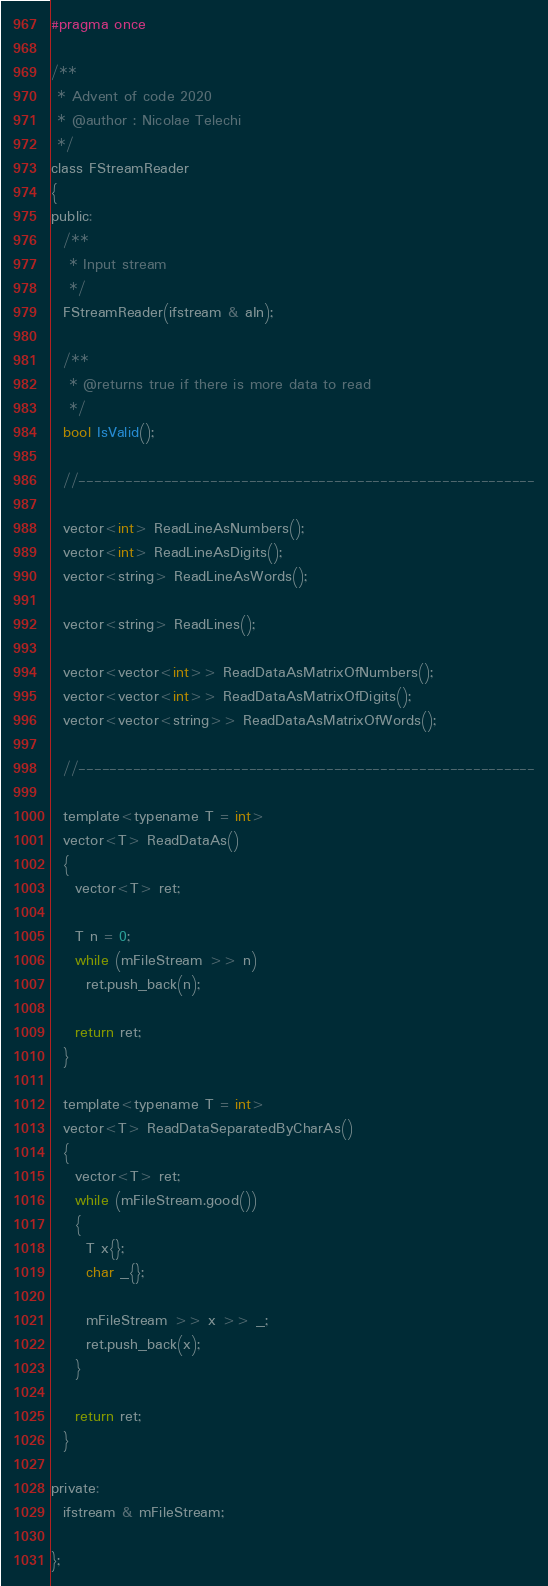Convert code to text. <code><loc_0><loc_0><loc_500><loc_500><_C_>#pragma once

/**
 * Advent of code 2020
 * @author : Nicolae Telechi
 */
class FStreamReader
{
public:
  /**
   * Input stream
   */
  FStreamReader(ifstream & aIn);

  /**
   * @returns true if there is more data to read
   */
  bool IsValid();

  //-----------------------------------------------------------

  vector<int> ReadLineAsNumbers();
  vector<int> ReadLineAsDigits();
  vector<string> ReadLineAsWords();

  vector<string> ReadLines();

  vector<vector<int>> ReadDataAsMatrixOfNumbers();
  vector<vector<int>> ReadDataAsMatrixOfDigits();
  vector<vector<string>> ReadDataAsMatrixOfWords();

  //-----------------------------------------------------------

  template<typename T = int>
  vector<T> ReadDataAs()
  {
    vector<T> ret;

    T n = 0;
    while (mFileStream >> n)
      ret.push_back(n);

    return ret;
  }

  template<typename T = int>
  vector<T> ReadDataSeparatedByCharAs()
  {
    vector<T> ret;
    while (mFileStream.good())
    {
      T x{};
      char _{};

      mFileStream >> x >> _;
      ret.push_back(x);
    }

    return ret;
  }

private:
  ifstream & mFileStream;

};
</code> 